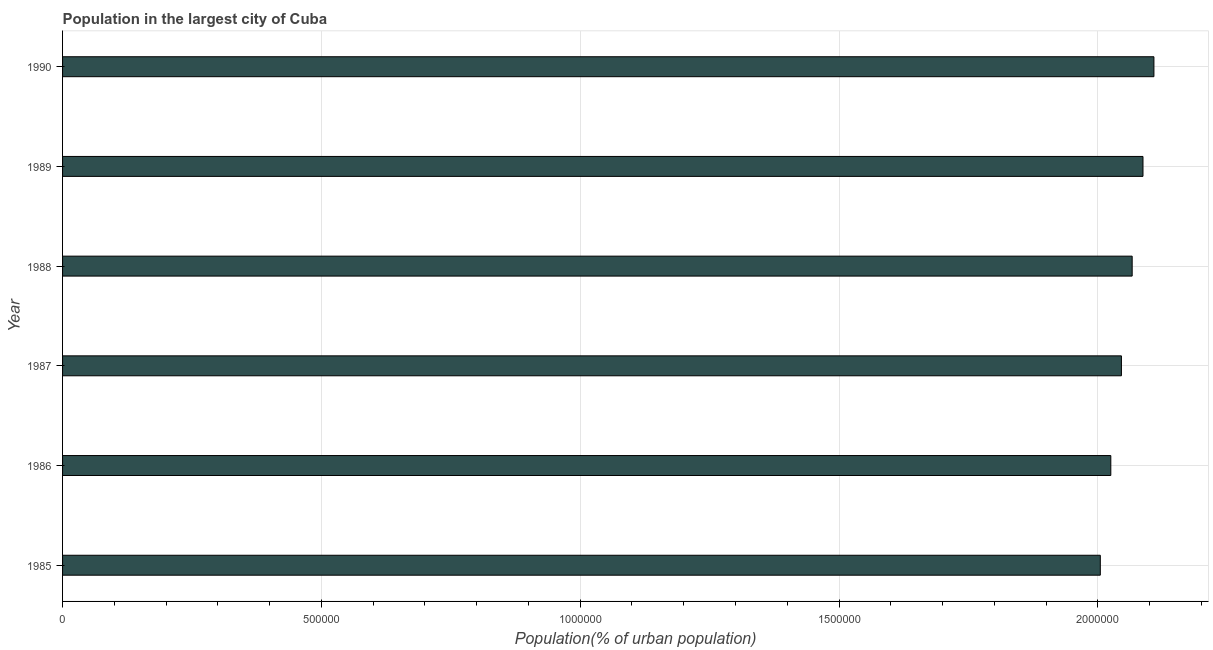What is the title of the graph?
Your response must be concise. Population in the largest city of Cuba. What is the label or title of the X-axis?
Your response must be concise. Population(% of urban population). What is the label or title of the Y-axis?
Your response must be concise. Year. What is the population in largest city in 1987?
Provide a succinct answer. 2.05e+06. Across all years, what is the maximum population in largest city?
Provide a short and direct response. 2.11e+06. Across all years, what is the minimum population in largest city?
Offer a very short reply. 2.00e+06. In which year was the population in largest city maximum?
Give a very brief answer. 1990. What is the sum of the population in largest city?
Keep it short and to the point. 1.23e+07. What is the difference between the population in largest city in 1988 and 1990?
Offer a terse response. -4.20e+04. What is the average population in largest city per year?
Your answer should be very brief. 2.06e+06. What is the median population in largest city?
Give a very brief answer. 2.06e+06. In how many years, is the population in largest city greater than 1700000 %?
Your answer should be very brief. 6. What is the difference between the highest and the second highest population in largest city?
Provide a succinct answer. 2.11e+04. What is the difference between the highest and the lowest population in largest city?
Keep it short and to the point. 1.04e+05. In how many years, is the population in largest city greater than the average population in largest city taken over all years?
Make the answer very short. 3. How many bars are there?
Your response must be concise. 6. Are all the bars in the graph horizontal?
Keep it short and to the point. Yes. How many years are there in the graph?
Provide a succinct answer. 6. What is the Population(% of urban population) in 1985?
Ensure brevity in your answer.  2.00e+06. What is the Population(% of urban population) of 1986?
Your answer should be very brief. 2.03e+06. What is the Population(% of urban population) of 1987?
Offer a terse response. 2.05e+06. What is the Population(% of urban population) in 1988?
Provide a succinct answer. 2.07e+06. What is the Population(% of urban population) of 1989?
Your response must be concise. 2.09e+06. What is the Population(% of urban population) of 1990?
Your answer should be compact. 2.11e+06. What is the difference between the Population(% of urban population) in 1985 and 1986?
Your answer should be very brief. -2.03e+04. What is the difference between the Population(% of urban population) in 1985 and 1987?
Ensure brevity in your answer.  -4.08e+04. What is the difference between the Population(% of urban population) in 1985 and 1988?
Offer a terse response. -6.16e+04. What is the difference between the Population(% of urban population) in 1985 and 1989?
Provide a short and direct response. -8.24e+04. What is the difference between the Population(% of urban population) in 1985 and 1990?
Your answer should be compact. -1.04e+05. What is the difference between the Population(% of urban population) in 1986 and 1987?
Make the answer very short. -2.05e+04. What is the difference between the Population(% of urban population) in 1986 and 1988?
Provide a succinct answer. -4.13e+04. What is the difference between the Population(% of urban population) in 1986 and 1989?
Offer a terse response. -6.21e+04. What is the difference between the Population(% of urban population) in 1986 and 1990?
Offer a terse response. -8.33e+04. What is the difference between the Population(% of urban population) in 1987 and 1988?
Your answer should be compact. -2.07e+04. What is the difference between the Population(% of urban population) in 1987 and 1989?
Offer a very short reply. -4.16e+04. What is the difference between the Population(% of urban population) in 1987 and 1990?
Your answer should be very brief. -6.28e+04. What is the difference between the Population(% of urban population) in 1988 and 1989?
Offer a terse response. -2.09e+04. What is the difference between the Population(% of urban population) in 1988 and 1990?
Make the answer very short. -4.20e+04. What is the difference between the Population(% of urban population) in 1989 and 1990?
Make the answer very short. -2.11e+04. What is the ratio of the Population(% of urban population) in 1985 to that in 1987?
Your answer should be compact. 0.98. What is the ratio of the Population(% of urban population) in 1985 to that in 1990?
Offer a very short reply. 0.95. What is the ratio of the Population(% of urban population) in 1986 to that in 1987?
Ensure brevity in your answer.  0.99. What is the ratio of the Population(% of urban population) in 1986 to that in 1988?
Offer a very short reply. 0.98. What is the ratio of the Population(% of urban population) in 1986 to that in 1989?
Provide a short and direct response. 0.97. What is the ratio of the Population(% of urban population) in 1986 to that in 1990?
Your answer should be compact. 0.96. What is the ratio of the Population(% of urban population) in 1987 to that in 1988?
Provide a succinct answer. 0.99. What is the ratio of the Population(% of urban population) in 1988 to that in 1989?
Make the answer very short. 0.99. 